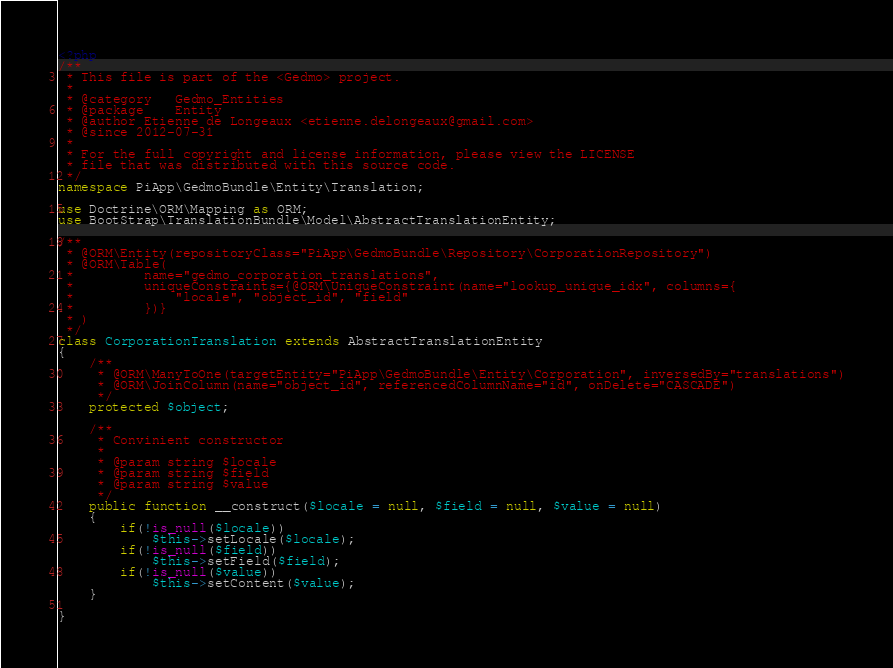Convert code to text. <code><loc_0><loc_0><loc_500><loc_500><_PHP_><?php 
/**
 * This file is part of the <Gedmo> project.
 *
 * @category   Gedmo_Entities
 * @package    Entity
 * @author Etienne de Longeaux <etienne.delongeaux@gmail.com>
 * @since 2012-07-31
 *
 * For the full copyright and license information, please view the LICENSE
 * file that was distributed with this source code.
 */
namespace PiApp\GedmoBundle\Entity\Translation;

use Doctrine\ORM\Mapping as ORM;
use BootStrap\TranslationBundle\Model\AbstractTranslationEntity;

/**
 * @ORM\Entity(repositoryClass="PiApp\GedmoBundle\Repository\CorporationRepository")
 * @ORM\Table(
 *         name="gedmo_corporation_translations",
 *         uniqueConstraints={@ORM\UniqueConstraint(name="lookup_unique_idx", columns={
 *             "locale", "object_id", "field"
 *         })}
 * )
 */
class CorporationTranslation extends AbstractTranslationEntity
{
	/**
	 * @ORM\ManyToOne(targetEntity="PiApp\GedmoBundle\Entity\Corporation", inversedBy="translations")
	 * @ORM\JoinColumn(name="object_id", referencedColumnName="id", onDelete="CASCADE")
	 */
	protected $object;
	
	/**
	 * Convinient constructor
	 *
	 * @param string $locale
	 * @param string $field
	 * @param string $value
	 */
	public function __construct($locale = null, $field = null, $value = null)
	{
		if(!is_null($locale))
			$this->setLocale($locale);
		if(!is_null($field))
			$this->setField($field);
		if(!is_null($value))
			$this->setContent($value);
	}	
		
}</code> 